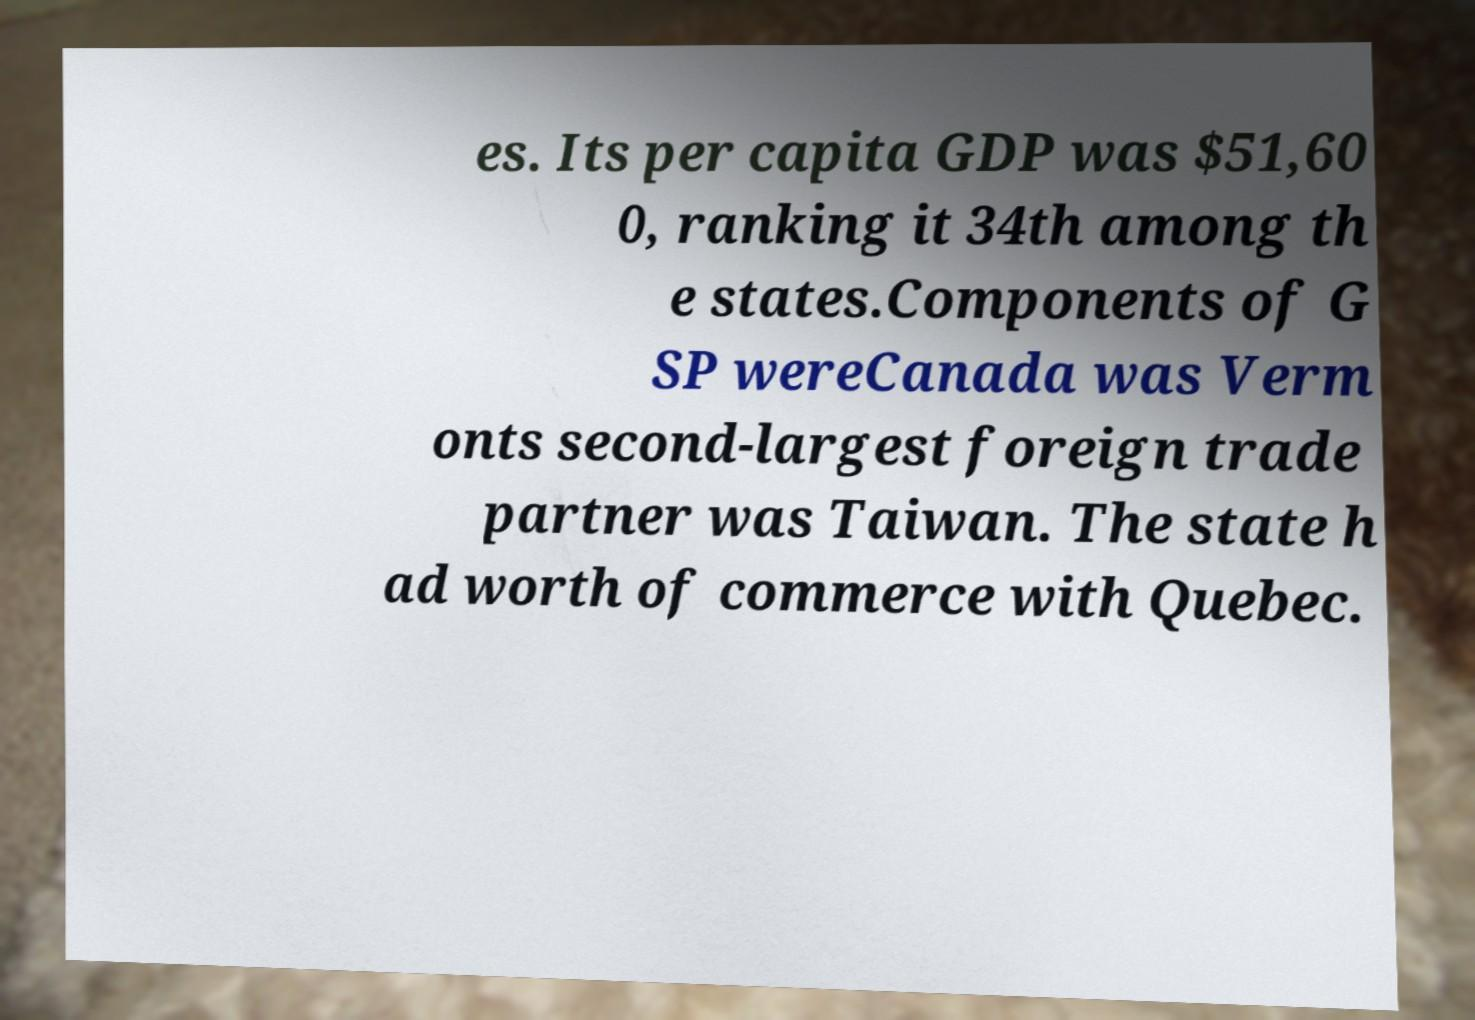What messages or text are displayed in this image? I need them in a readable, typed format. es. Its per capita GDP was $51,60 0, ranking it 34th among th e states.Components of G SP wereCanada was Verm onts second-largest foreign trade partner was Taiwan. The state h ad worth of commerce with Quebec. 